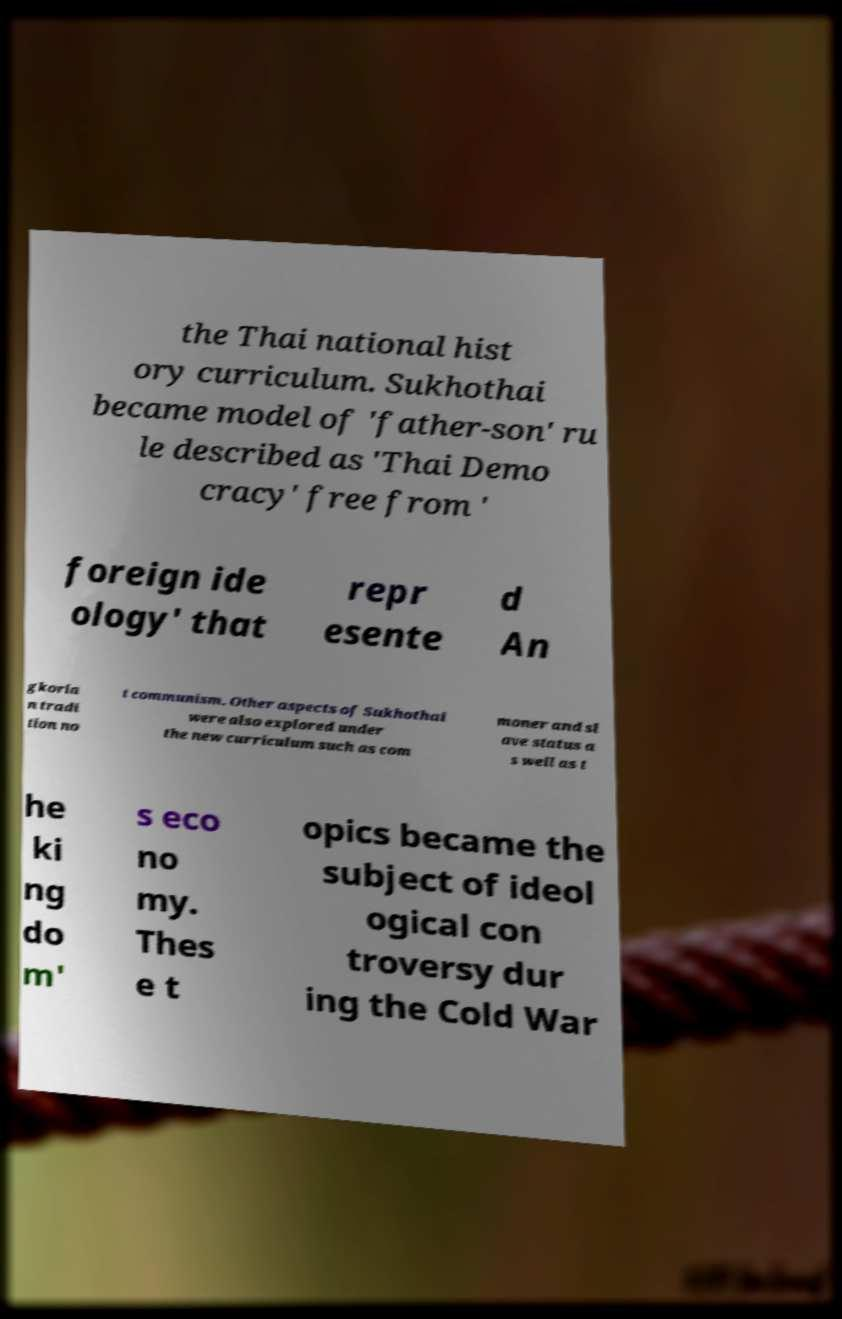What messages or text are displayed in this image? I need them in a readable, typed format. the Thai national hist ory curriculum. Sukhothai became model of 'father-son' ru le described as 'Thai Demo cracy' free from ' foreign ide ology' that repr esente d An gkoria n tradi tion no t communism. Other aspects of Sukhothai were also explored under the new curriculum such as com moner and sl ave status a s well as t he ki ng do m' s eco no my. Thes e t opics became the subject of ideol ogical con troversy dur ing the Cold War 